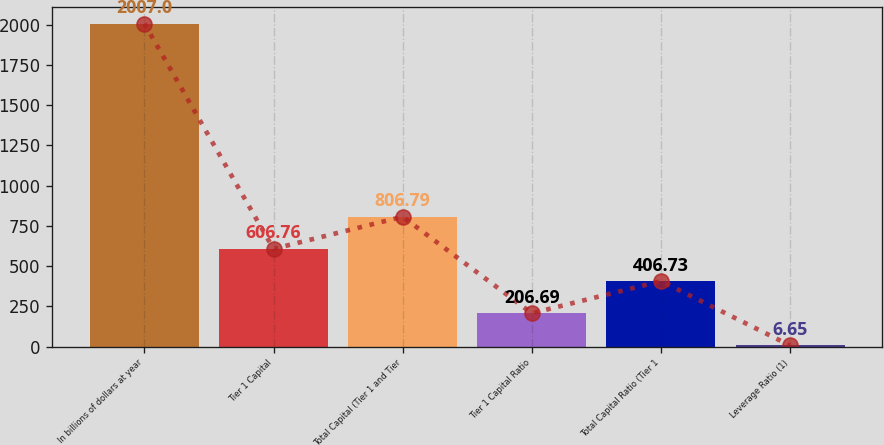Convert chart. <chart><loc_0><loc_0><loc_500><loc_500><bar_chart><fcel>In billions of dollars at year<fcel>Tier 1 Capital<fcel>Total Capital (Tier 1 and Tier<fcel>Tier 1 Capital Ratio<fcel>Total Capital Ratio (Tier 1<fcel>Leverage Ratio (1)<nl><fcel>2007<fcel>606.76<fcel>806.79<fcel>206.69<fcel>406.73<fcel>6.65<nl></chart> 